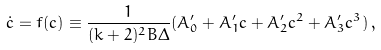Convert formula to latex. <formula><loc_0><loc_0><loc_500><loc_500>\dot { c } = f ( c ) \equiv \frac { 1 } { ( k + 2 ) ^ { 2 } B \Delta } ( A ^ { \prime } _ { 0 } + A ^ { \prime } _ { 1 } c + A ^ { \prime } _ { 2 } c ^ { 2 } + A ^ { \prime } _ { 3 } c ^ { 3 } ) \, ,</formula> 